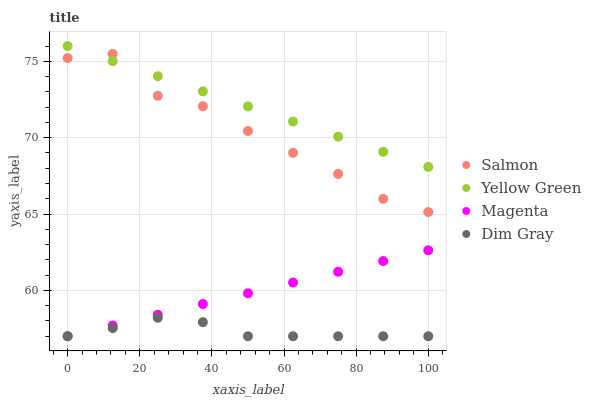Does Dim Gray have the minimum area under the curve?
Answer yes or no. Yes. Does Yellow Green have the maximum area under the curve?
Answer yes or no. Yes. Does Salmon have the minimum area under the curve?
Answer yes or no. No. Does Salmon have the maximum area under the curve?
Answer yes or no. No. Is Yellow Green the smoothest?
Answer yes or no. Yes. Is Salmon the roughest?
Answer yes or no. Yes. Is Dim Gray the smoothest?
Answer yes or no. No. Is Dim Gray the roughest?
Answer yes or no. No. Does Magenta have the lowest value?
Answer yes or no. Yes. Does Salmon have the lowest value?
Answer yes or no. No. Does Yellow Green have the highest value?
Answer yes or no. Yes. Does Salmon have the highest value?
Answer yes or no. No. Is Dim Gray less than Salmon?
Answer yes or no. Yes. Is Yellow Green greater than Dim Gray?
Answer yes or no. Yes. Does Salmon intersect Yellow Green?
Answer yes or no. Yes. Is Salmon less than Yellow Green?
Answer yes or no. No. Is Salmon greater than Yellow Green?
Answer yes or no. No. Does Dim Gray intersect Salmon?
Answer yes or no. No. 